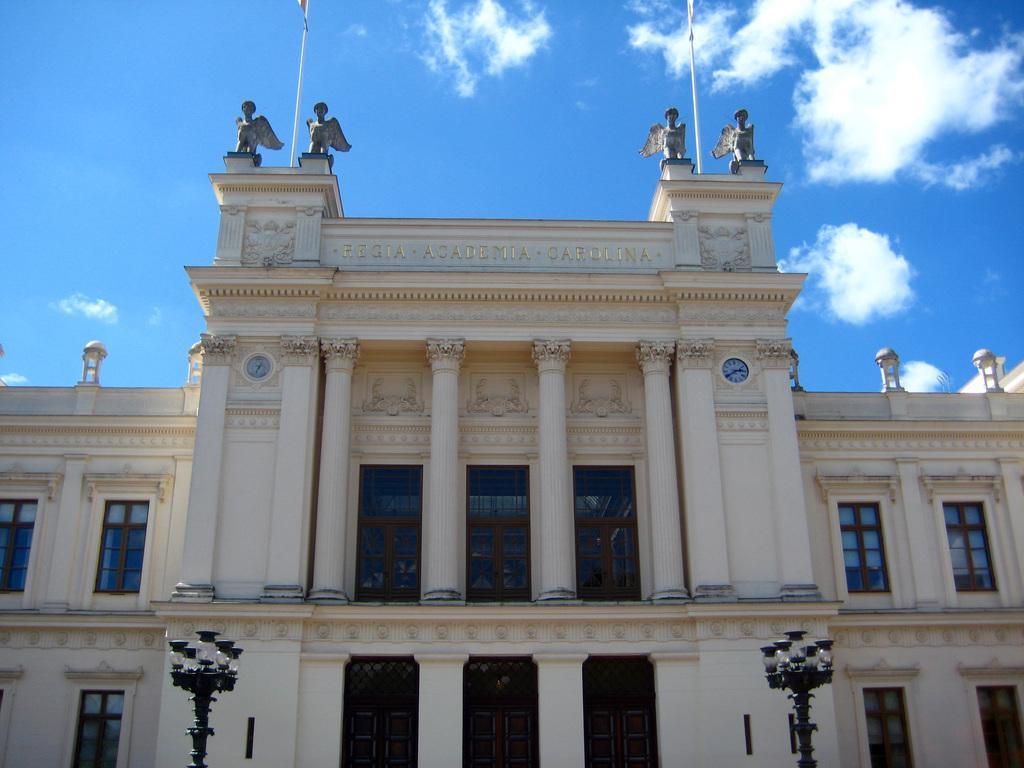Please provide a concise description of this image. In this picture we can see a building, light poles, windows, pillars, clocks, statues, flag poles and in the background we can see the sky with clouds. 